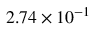<formula> <loc_0><loc_0><loc_500><loc_500>2 . 7 4 \times 1 0 ^ { - 1 }</formula> 